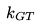Convert formula to latex. <formula><loc_0><loc_0><loc_500><loc_500>k _ { G T }</formula> 